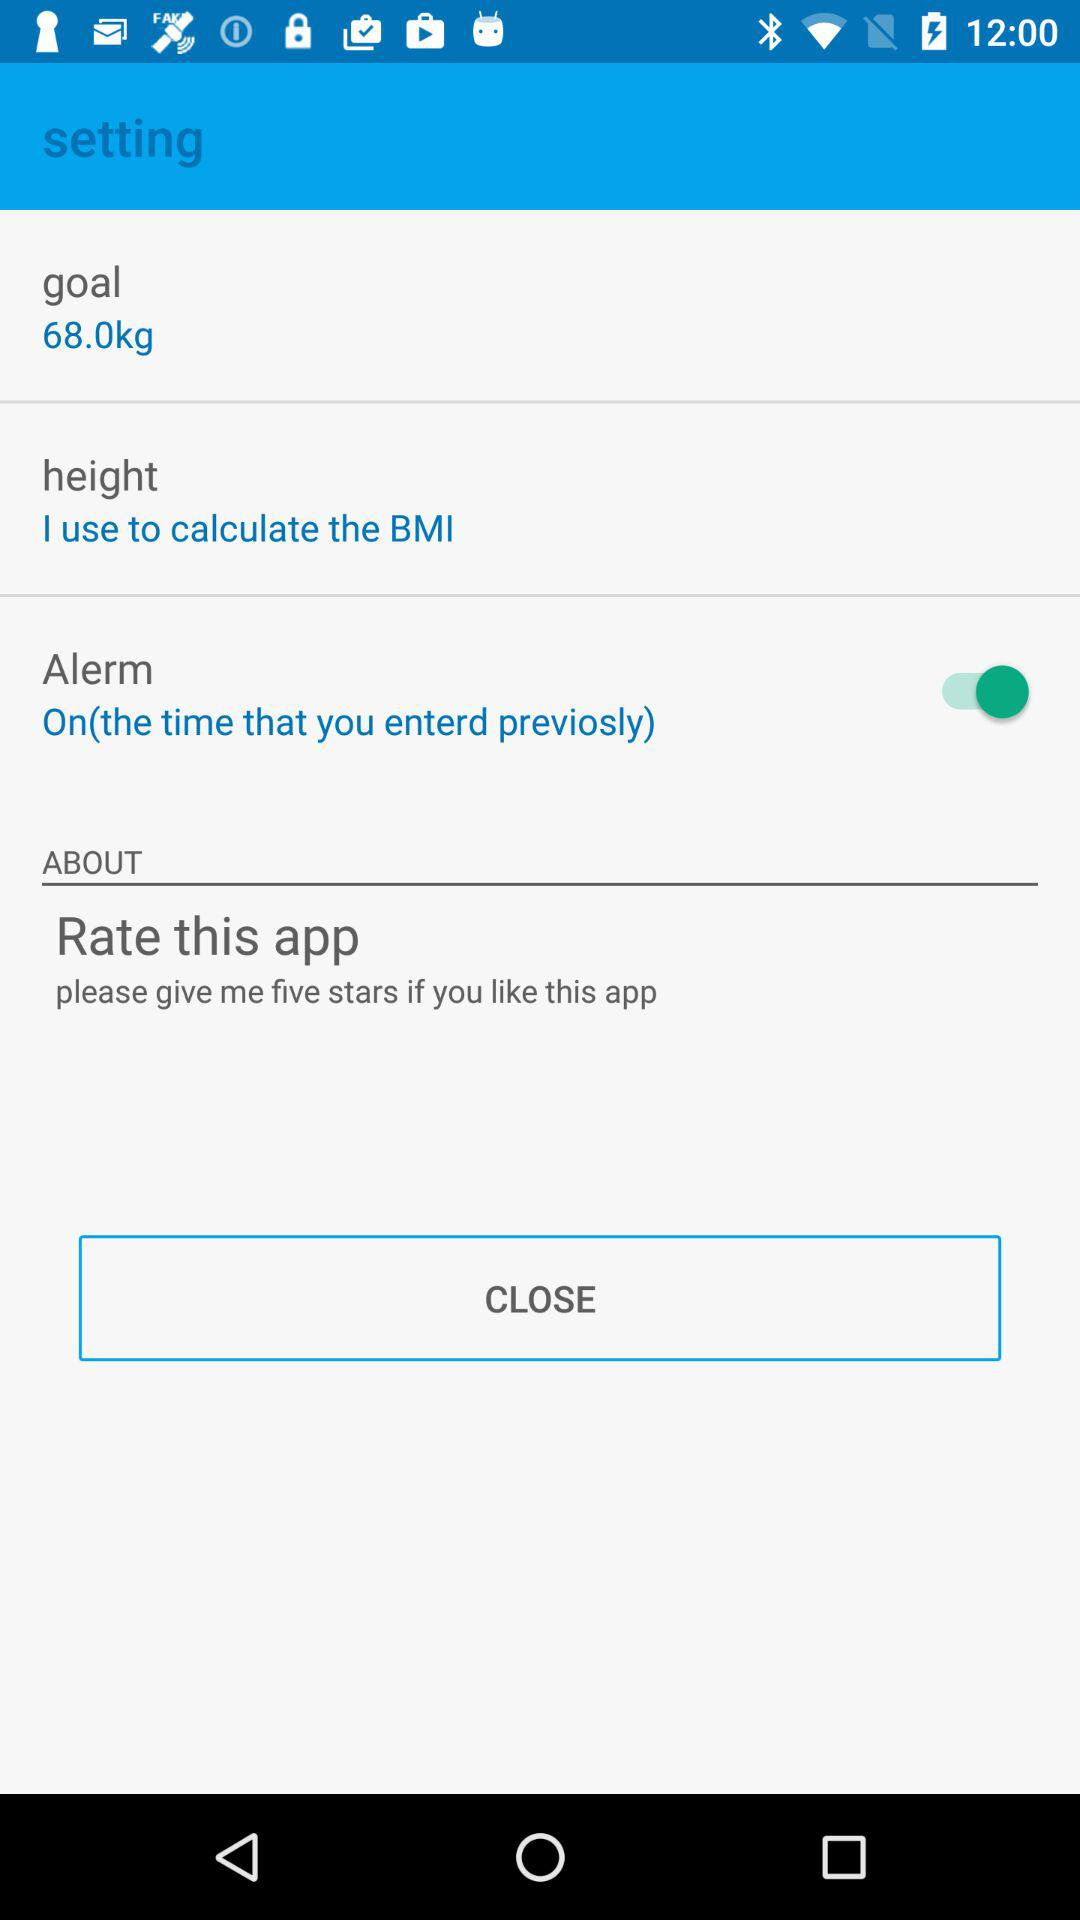What is the status of "Alerm"? The status of "Alerm" is "on". 